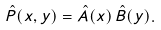Convert formula to latex. <formula><loc_0><loc_0><loc_500><loc_500>\hat { P } ( x , y ) = \hat { A } ( x ) \, \hat { B } ( y ) .</formula> 